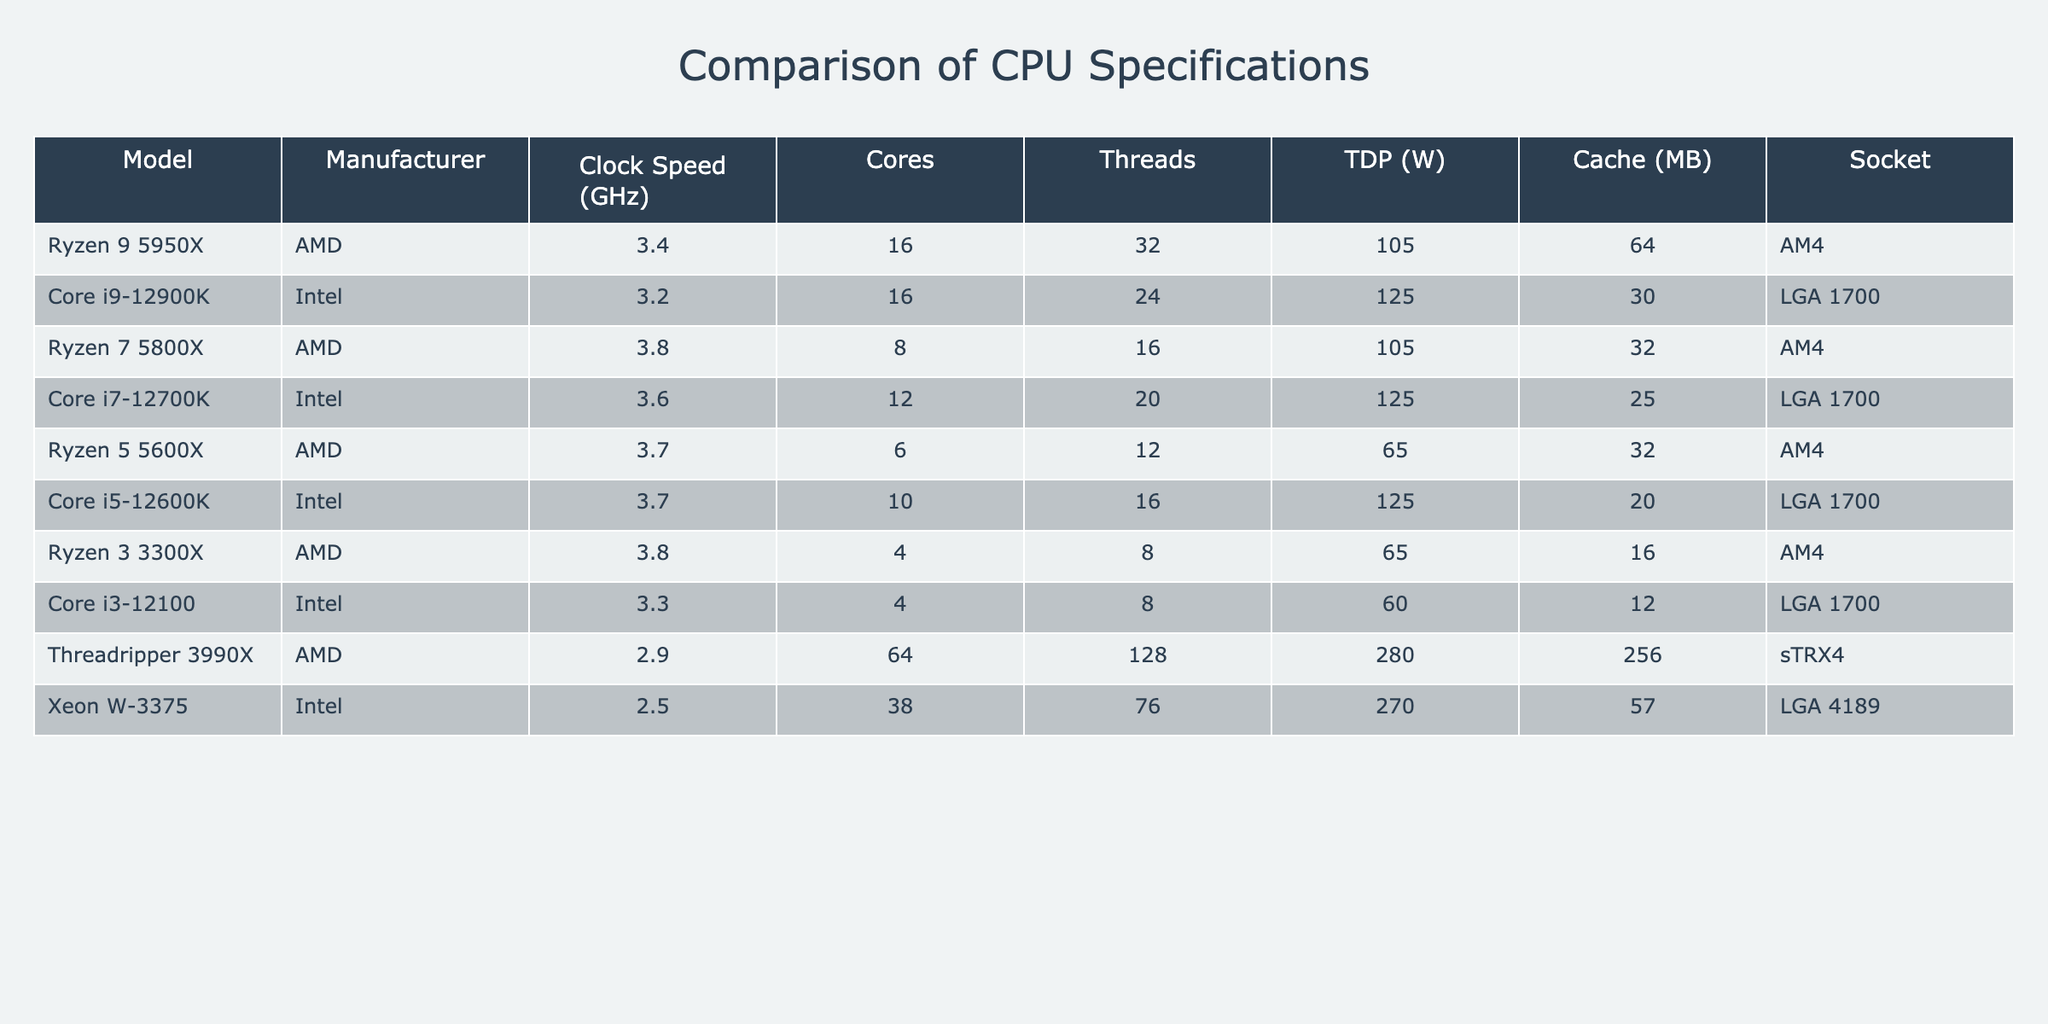What is the clock speed of the Core i9-12900K? From the table, I can see that the Core i9-12900K has a clock speed listed under the "Clock Speed (GHz)" column. The value adjacent to this model is 3.2 GHz.
Answer: 3.2 GHz Which CPU has the highest number of cores? By examining the "Cores" column, I can compare the values for each CPU. The Threadripper 3990X has 64 cores, which is the highest value compared to other CPUs listed.
Answer: Threadripper 3990X What is the TDP of the Ryzen 7 5800X and the Ryzen 5 5600X combined? I will locate the TDP values for both models in the "TDP (W)" column. The Ryzen 7 5800X has a TDP of 105 W and the Ryzen 5 5600X has a TDP of 65 W. When I add these together: 105 + 65 = 170.
Answer: 170 W Does the Xeon W-3375 have more cache than the Ryzen 3 3300X? I compare the values of both CPUs in the "Cache (MB)" column. The Xeon W-3375 has 57 MB of cache, while the Ryzen 3 3300X has 16 MB. Since 57 is greater than 16, the statement is true.
Answer: Yes What is the average clock speed of all the AMD CPUs listed? I will first extract the clock speeds for all AMD models: 3.4 (Ryzen 9 5950X), 3.8 (Ryzen 7 5800X), 3.7 (Ryzen 5 5600X), and 3.8 (Ryzen 3 3300X). I sum these values: 3.4 + 3.8 + 3.7 + 3.8 = 14.7. There are 4 AMD CPUs, so the average is 14.7 / 4 = 3.675.
Answer: 3.675 GHz 